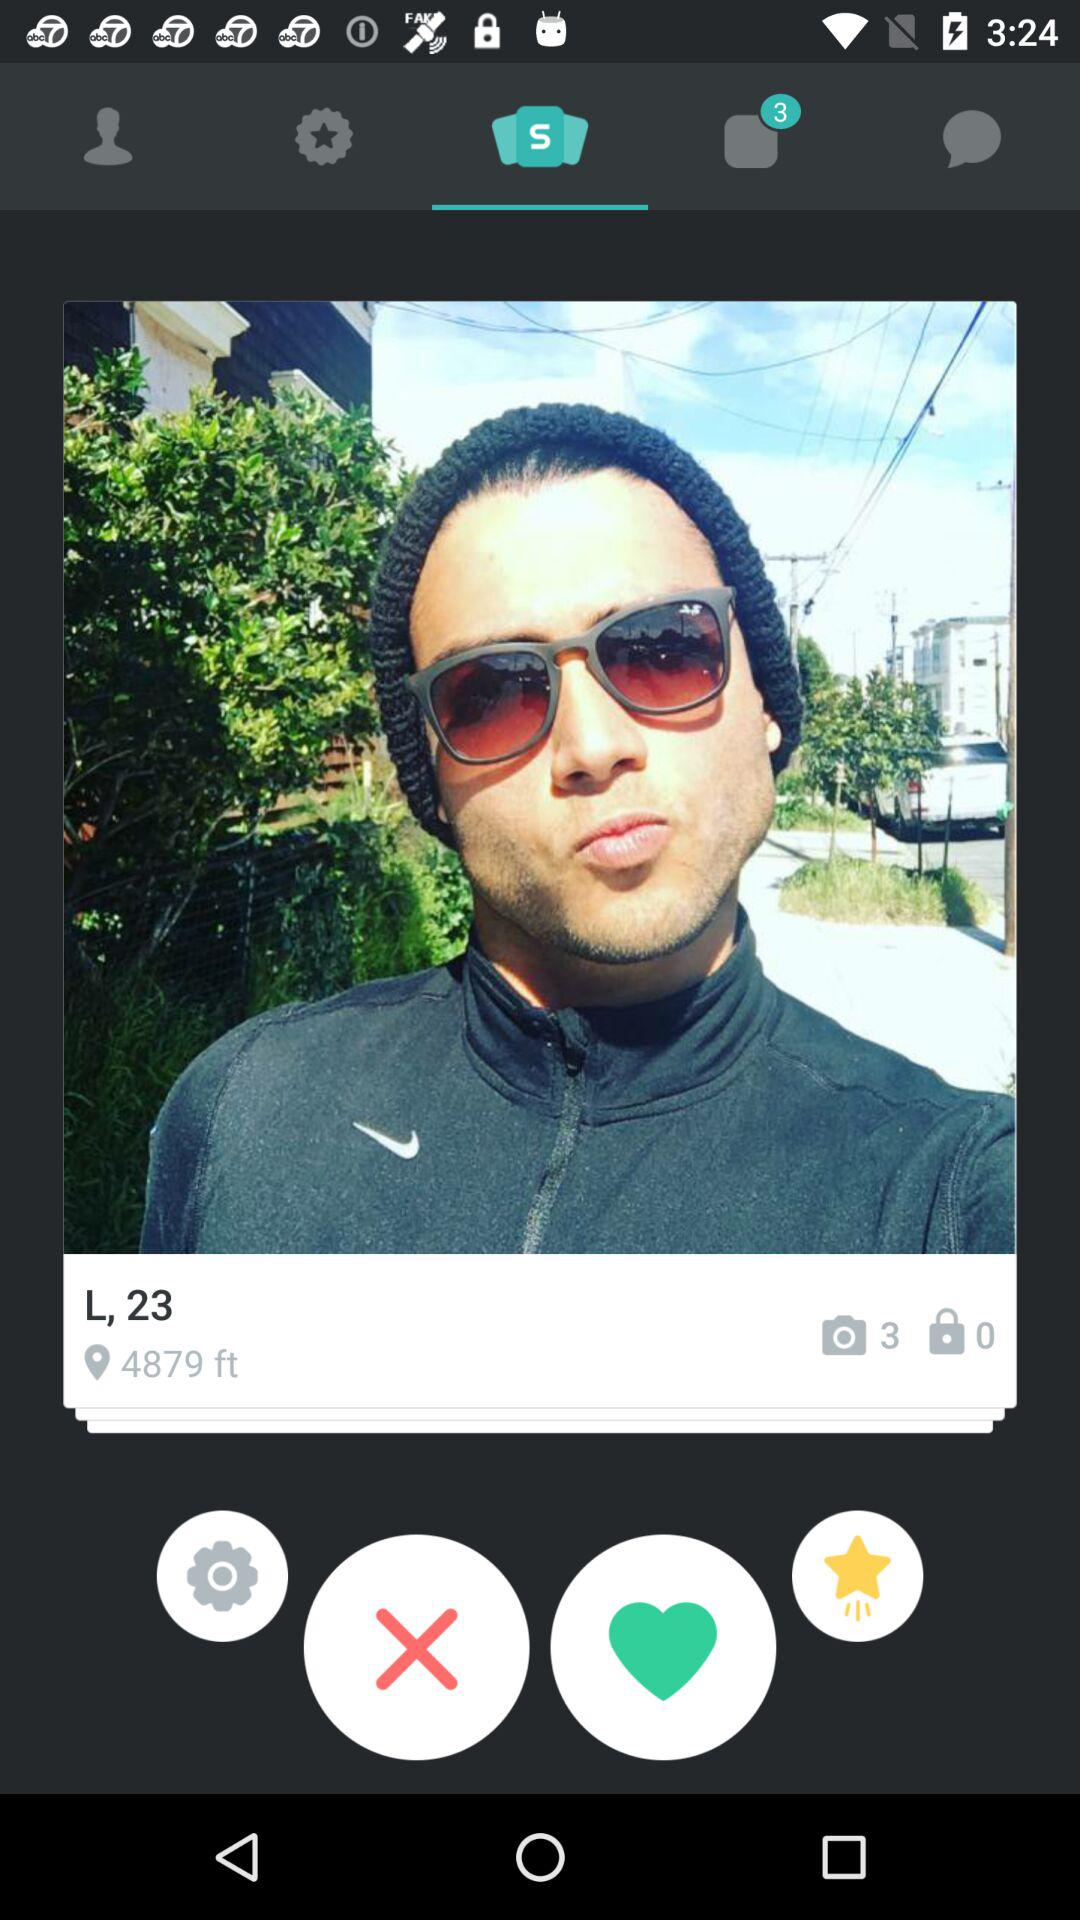What is the username? The username is "L". 